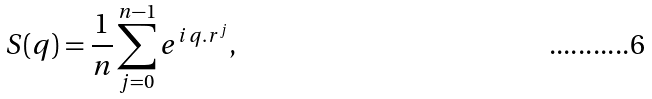<formula> <loc_0><loc_0><loc_500><loc_500>S ( { q } ) = { \frac { 1 } { n } } \sum _ { j = 0 } ^ { n - 1 } e ^ { i \, { q } . { r } ^ { j } } ,</formula> 